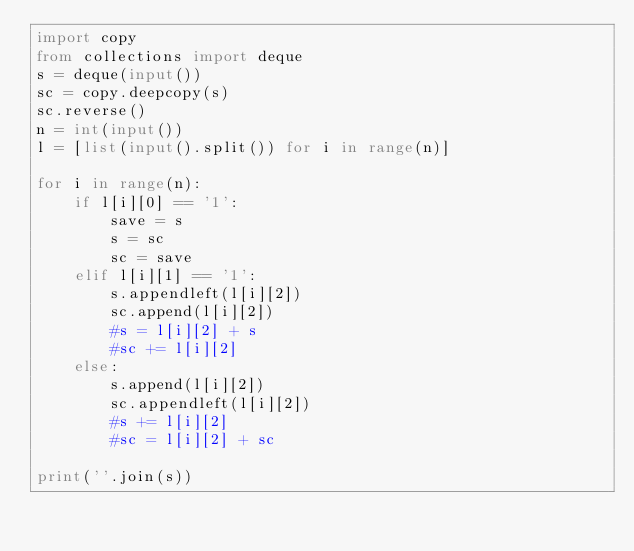<code> <loc_0><loc_0><loc_500><loc_500><_Python_>import copy
from collections import deque
s = deque(input())
sc = copy.deepcopy(s) 
sc.reverse()
n = int(input())
l = [list(input().split()) for i in range(n)]

for i in range(n):
    if l[i][0] == '1':
        save = s
        s = sc
        sc = save
    elif l[i][1] == '1':
        s.appendleft(l[i][2])
        sc.append(l[i][2])
        #s = l[i][2] + s
        #sc += l[i][2]
    else:
        s.append(l[i][2])
        sc.appendleft(l[i][2])
        #s += l[i][2]
        #sc = l[i][2] + sc

print(''.join(s))
</code> 